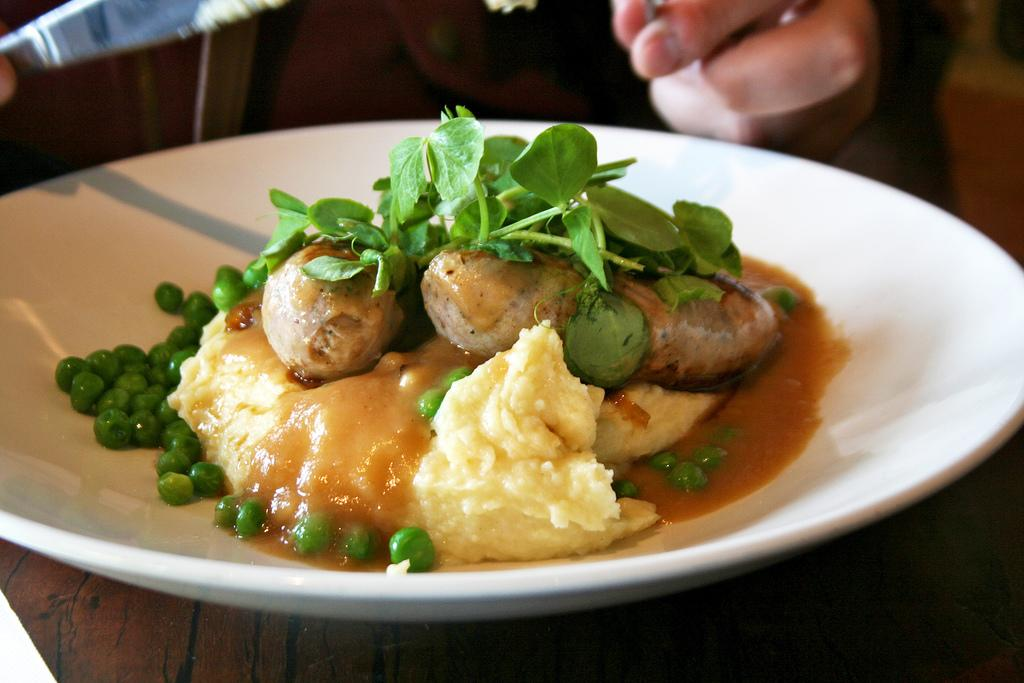What is there is a plate in the center of the image, what is on the plate? The plate contains peas, green leafy vegetables, and other food items. Can you describe the other food items on the plate? Unfortunately, the specific other food items are not mentioned in the facts provided. Is there anyone else in the image besides the plate? Yes, there is a person in the background of the image. What type of shoe is the person wearing in the image? There is no information about the person's shoes in the image, as the focus is on the plate and its contents. 